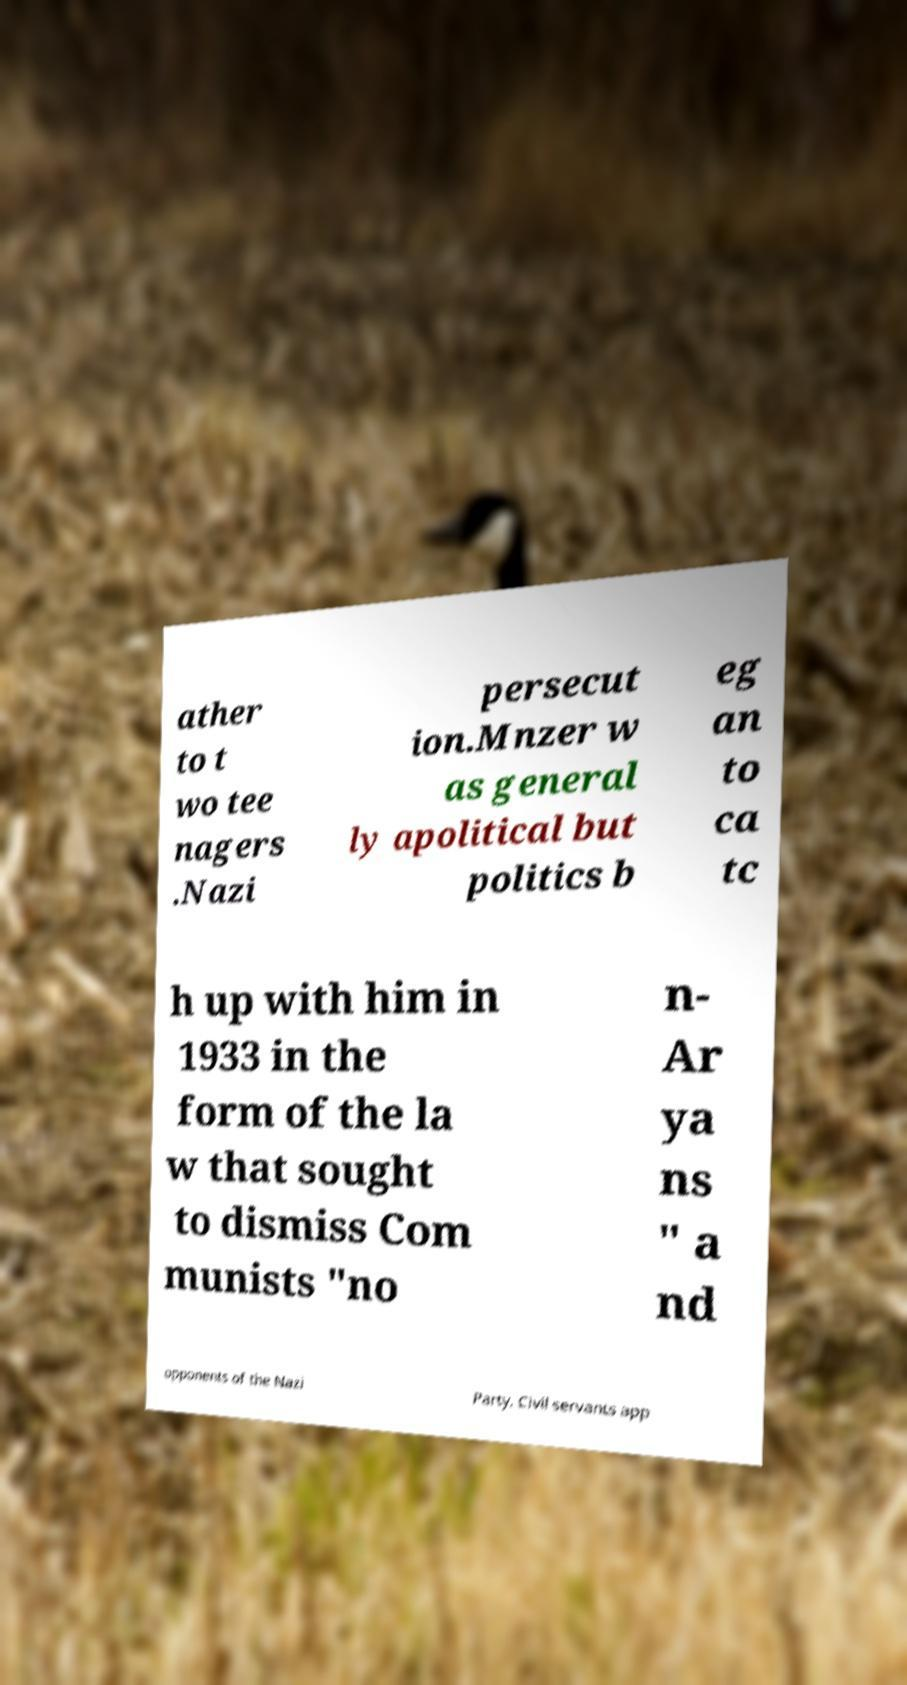Can you read and provide the text displayed in the image?This photo seems to have some interesting text. Can you extract and type it out for me? ather to t wo tee nagers .Nazi persecut ion.Mnzer w as general ly apolitical but politics b eg an to ca tc h up with him in 1933 in the form of the la w that sought to dismiss Com munists "no n- Ar ya ns " a nd opponents of the Nazi Party. Civil servants app 